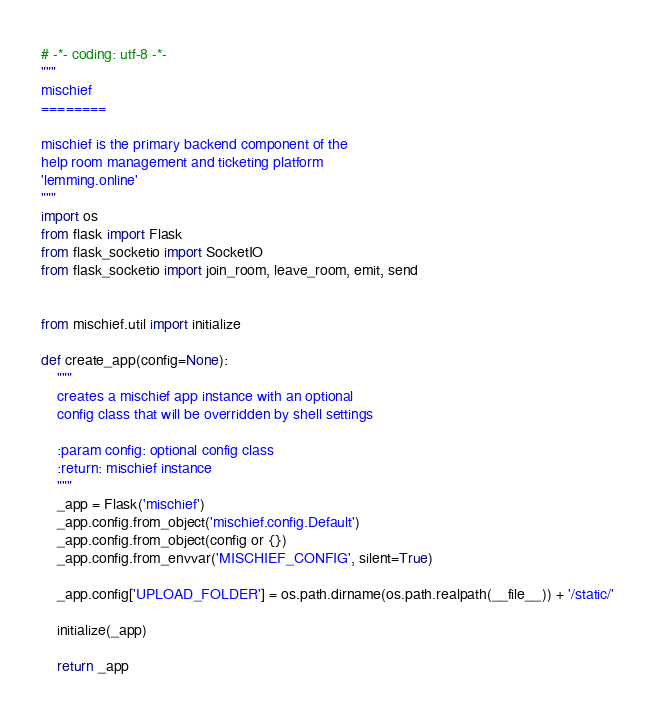<code> <loc_0><loc_0><loc_500><loc_500><_Python_># -*- coding: utf-8 -*-
"""
mischief
========

mischief is the primary backend component of the
help room management and ticketing platform
'lemming.online'
"""
import os
from flask import Flask
from flask_socketio import SocketIO
from flask_socketio import join_room, leave_room, emit, send


from mischief.util import initialize

def create_app(config=None):
    """
    creates a mischief app instance with an optional
    config class that will be overridden by shell settings

    :param config: optional config class
    :return: mischief instance
    """
    _app = Flask('mischief')
    _app.config.from_object('mischief.config.Default')
    _app.config.from_object(config or {})
    _app.config.from_envvar('MISCHIEF_CONFIG', silent=True)

    _app.config['UPLOAD_FOLDER'] = os.path.dirname(os.path.realpath(__file__)) + '/static/'

    initialize(_app)

    return _app
</code> 